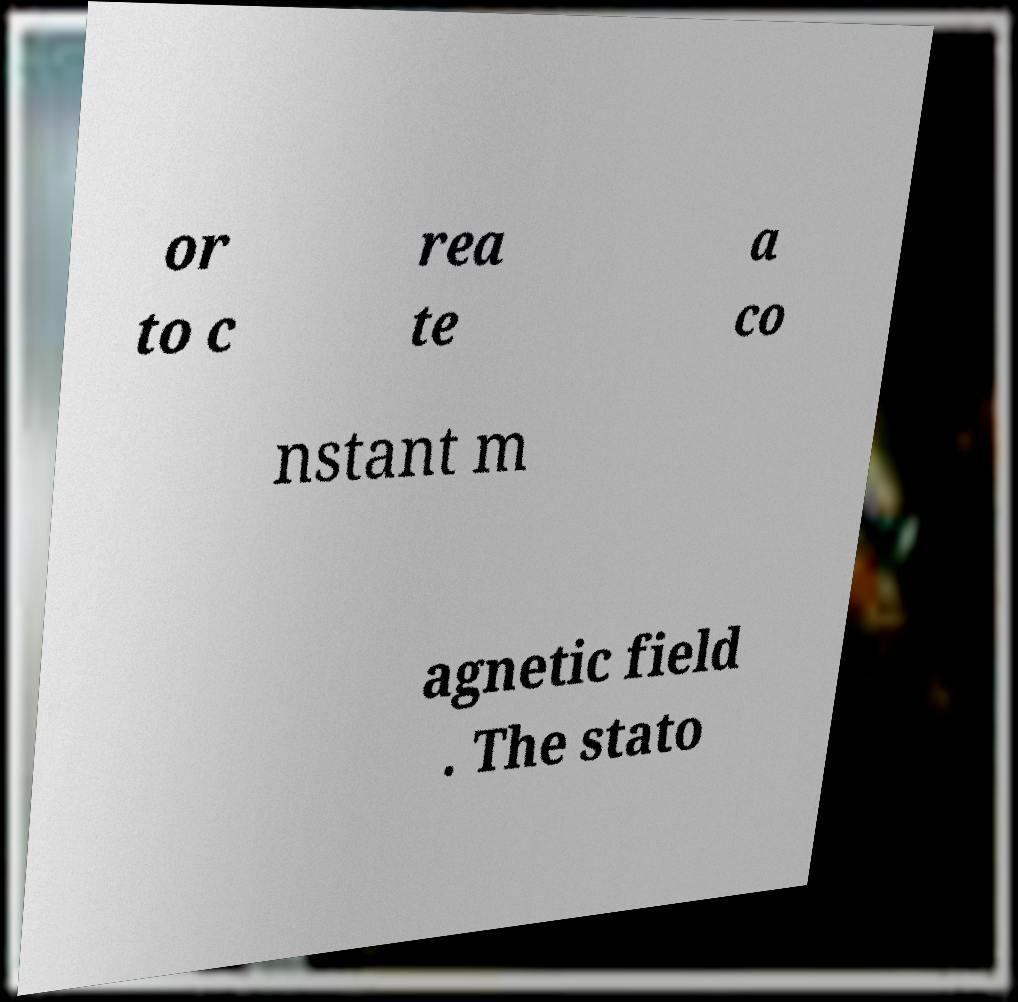There's text embedded in this image that I need extracted. Can you transcribe it verbatim? or to c rea te a co nstant m agnetic field . The stato 